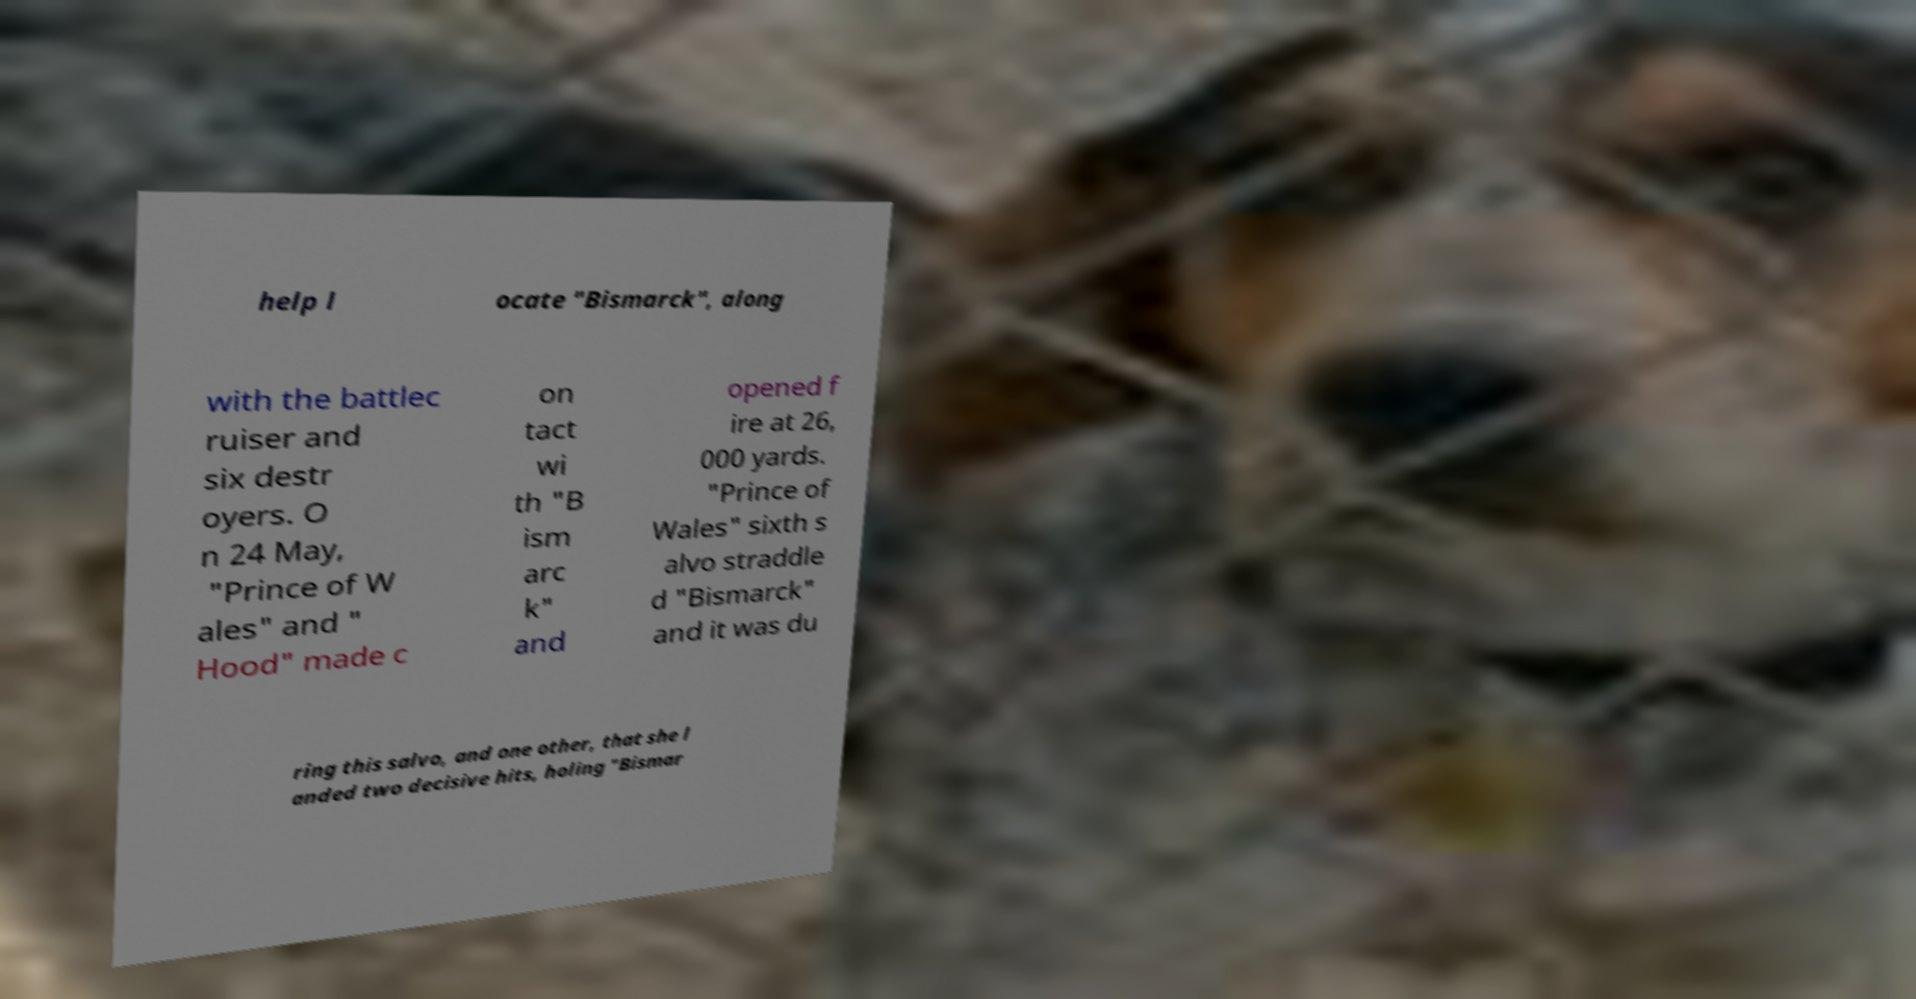I need the written content from this picture converted into text. Can you do that? help l ocate "Bismarck", along with the battlec ruiser and six destr oyers. O n 24 May, "Prince of W ales" and " Hood" made c on tact wi th "B ism arc k" and opened f ire at 26, 000 yards. "Prince of Wales" sixth s alvo straddle d "Bismarck" and it was du ring this salvo, and one other, that she l anded two decisive hits, holing "Bismar 